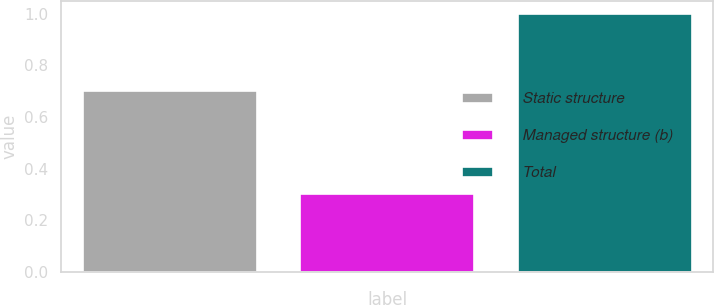Convert chart to OTSL. <chart><loc_0><loc_0><loc_500><loc_500><bar_chart><fcel>Static structure<fcel>Managed structure (b)<fcel>Total<nl><fcel>0.7<fcel>0.3<fcel>1<nl></chart> 